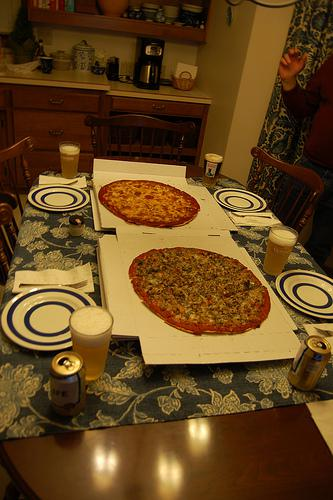Question: what color is the table?
Choices:
A. Red.
B. Brown.
C. Yellow.
D. White.
Answer with the letter. Answer: B Question: what is the table made of?
Choices:
A. Metal.
B. Glass.
C. Wicker.
D. Wood.
Answer with the letter. Answer: D Question: how many filled cups are on the table?
Choices:
A. 1.
B. 3.
C. 2.
D. 4.
Answer with the letter. Answer: B Question: how many pizzas are on the table?
Choices:
A. 1.
B. 3.
C. 2.
D. 4.
Answer with the letter. Answer: C Question: how many chairs are around the table?
Choices:
A. 1.
B. 2.
C. 4.
D. 3.
Answer with the letter. Answer: C 